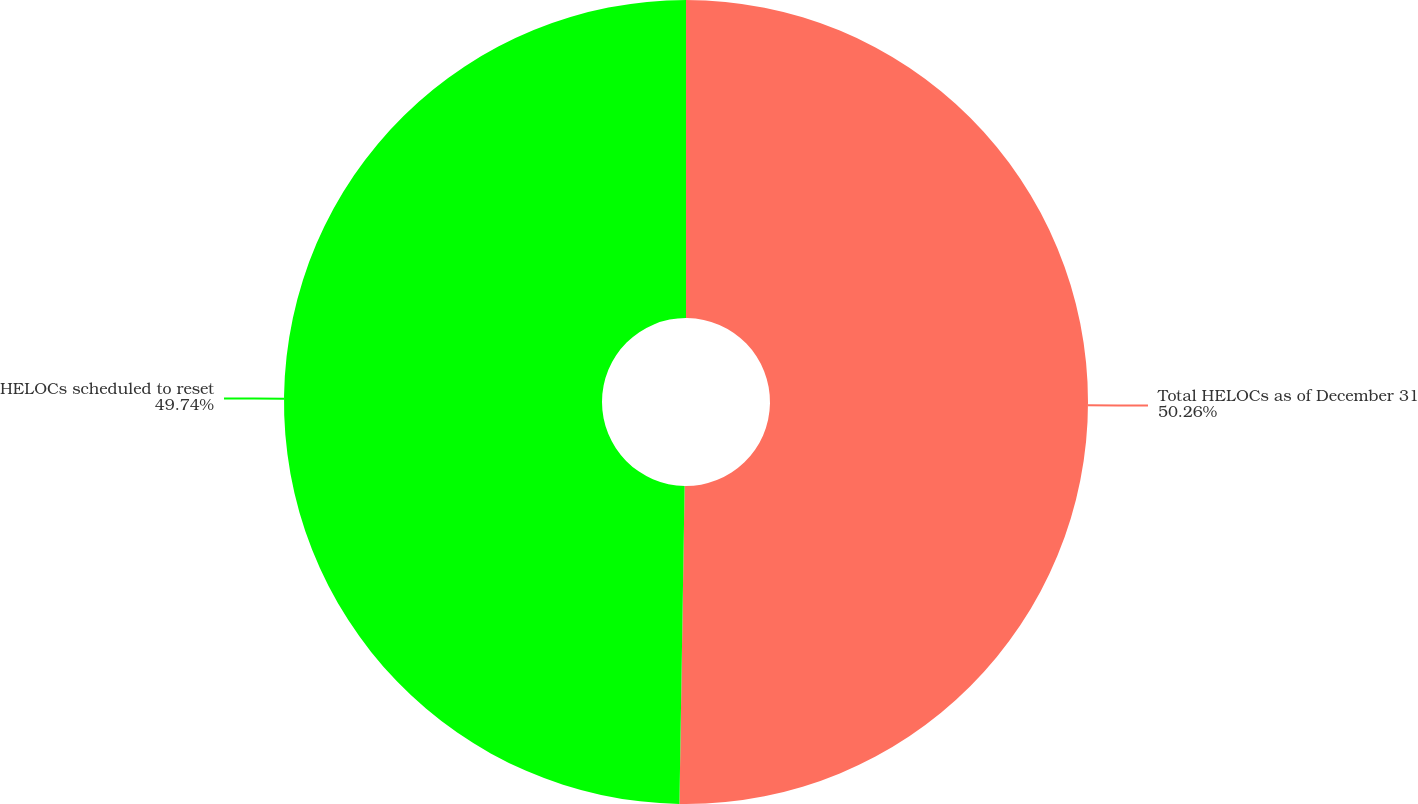Convert chart to OTSL. <chart><loc_0><loc_0><loc_500><loc_500><pie_chart><fcel>Total HELOCs as of December 31<fcel>HELOCs scheduled to reset<nl><fcel>50.26%<fcel>49.74%<nl></chart> 